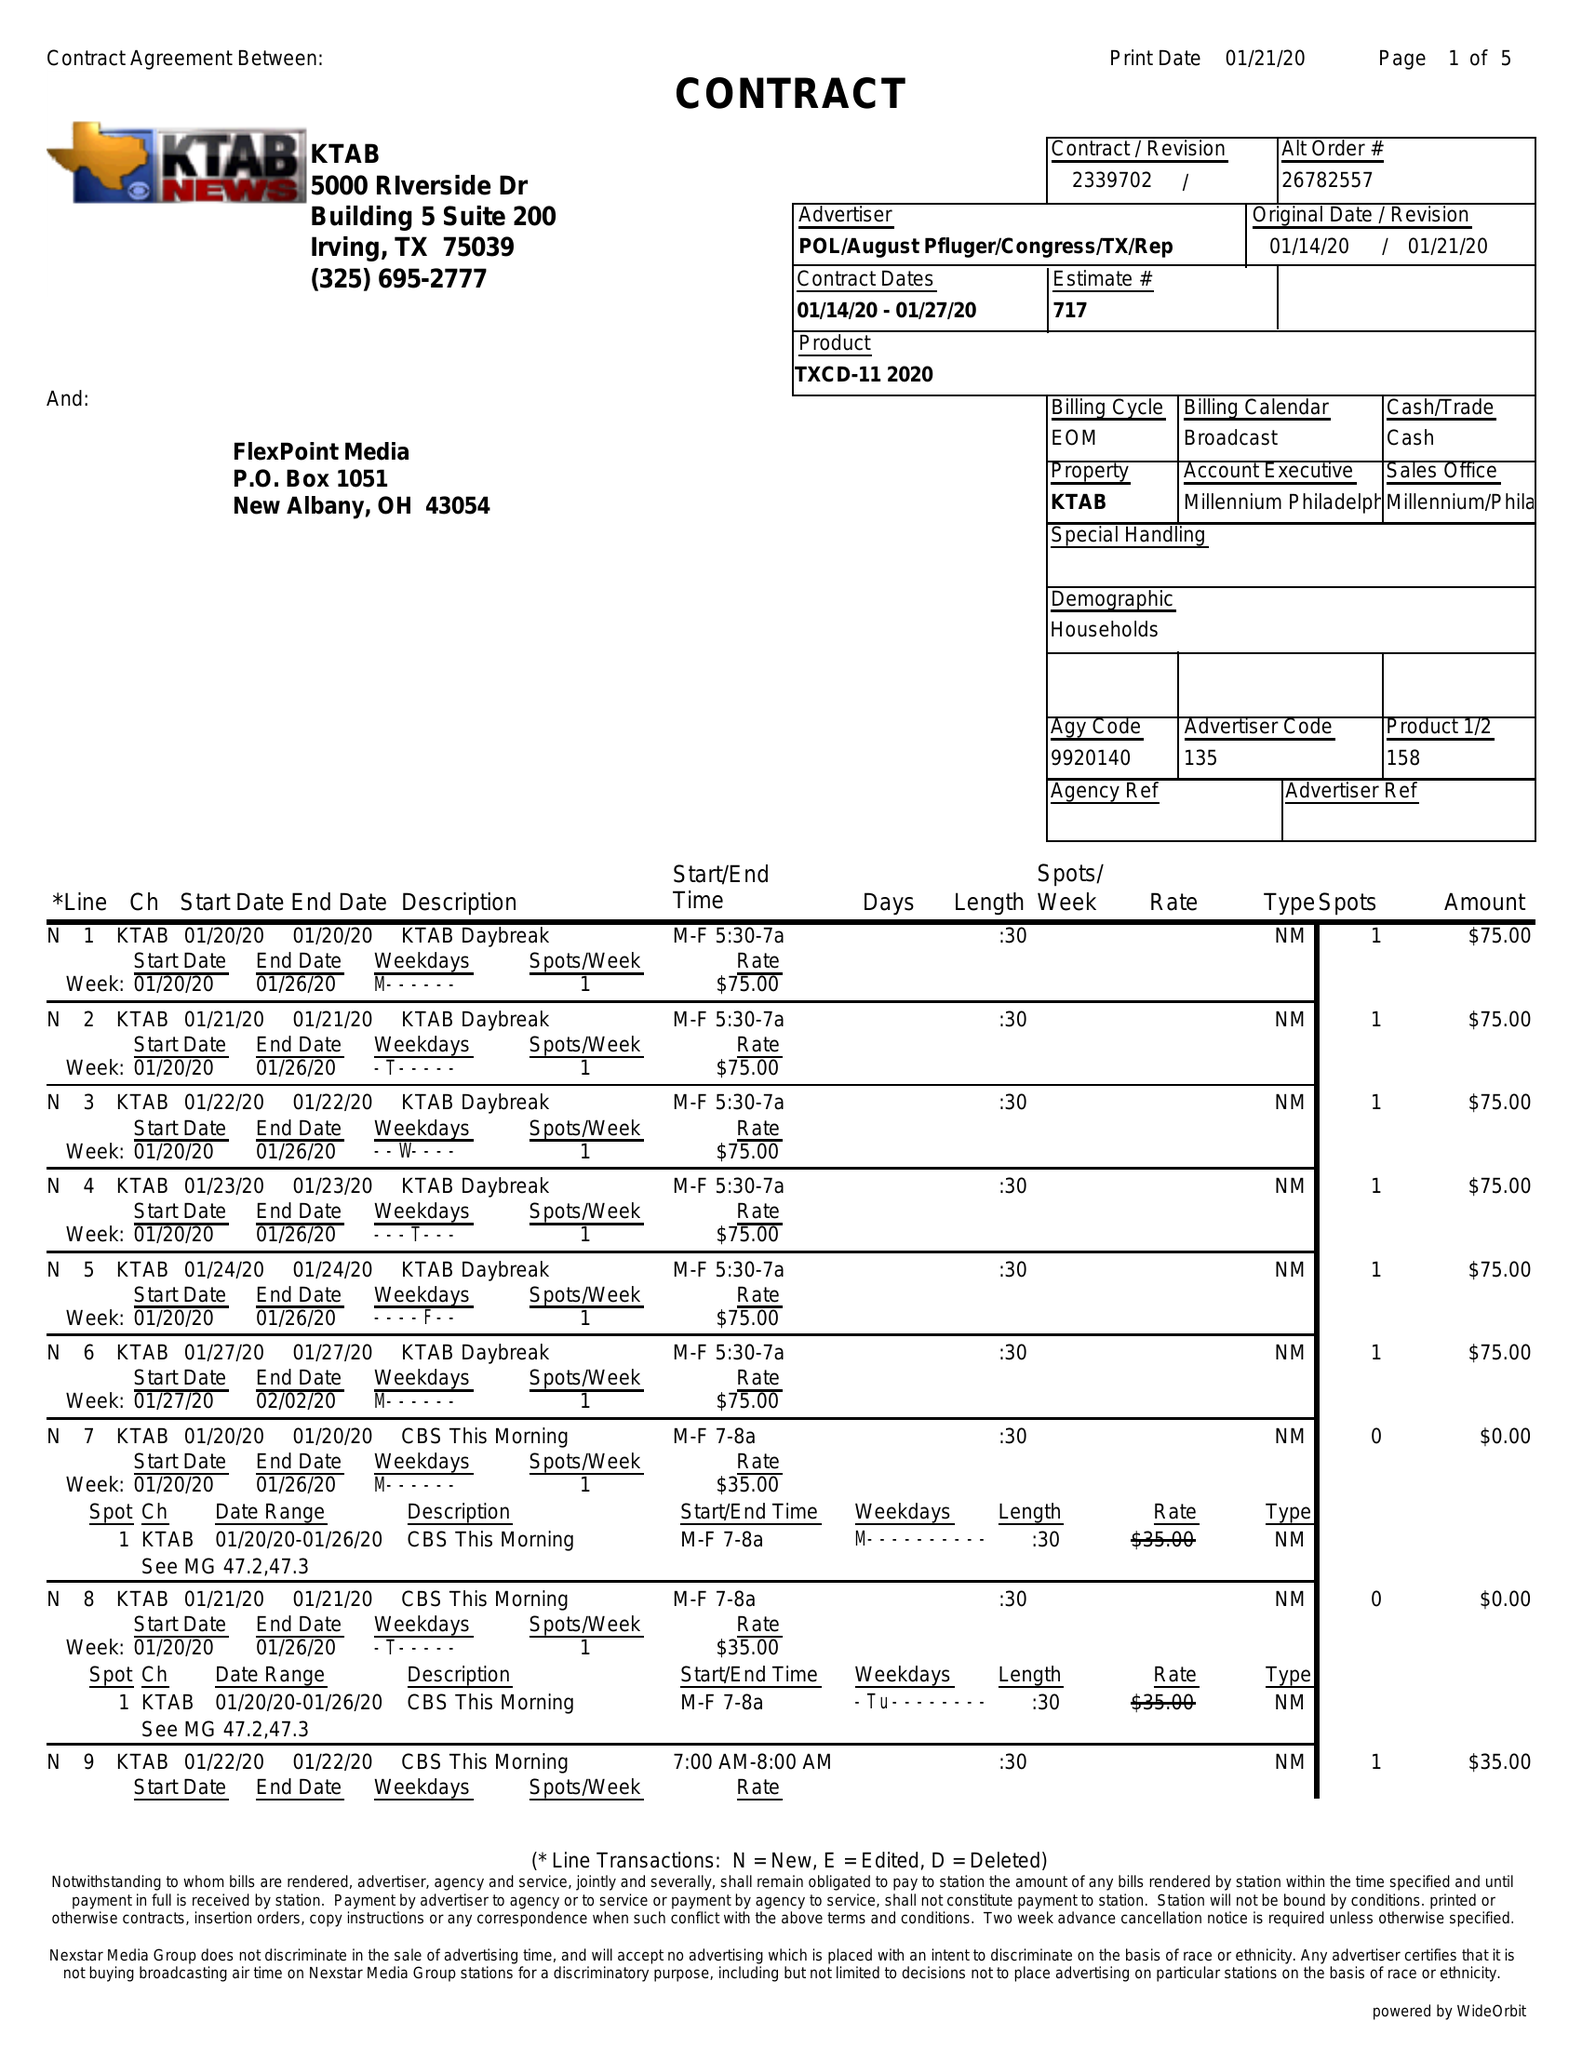What is the value for the gross_amount?
Answer the question using a single word or phrase. 8770.00 